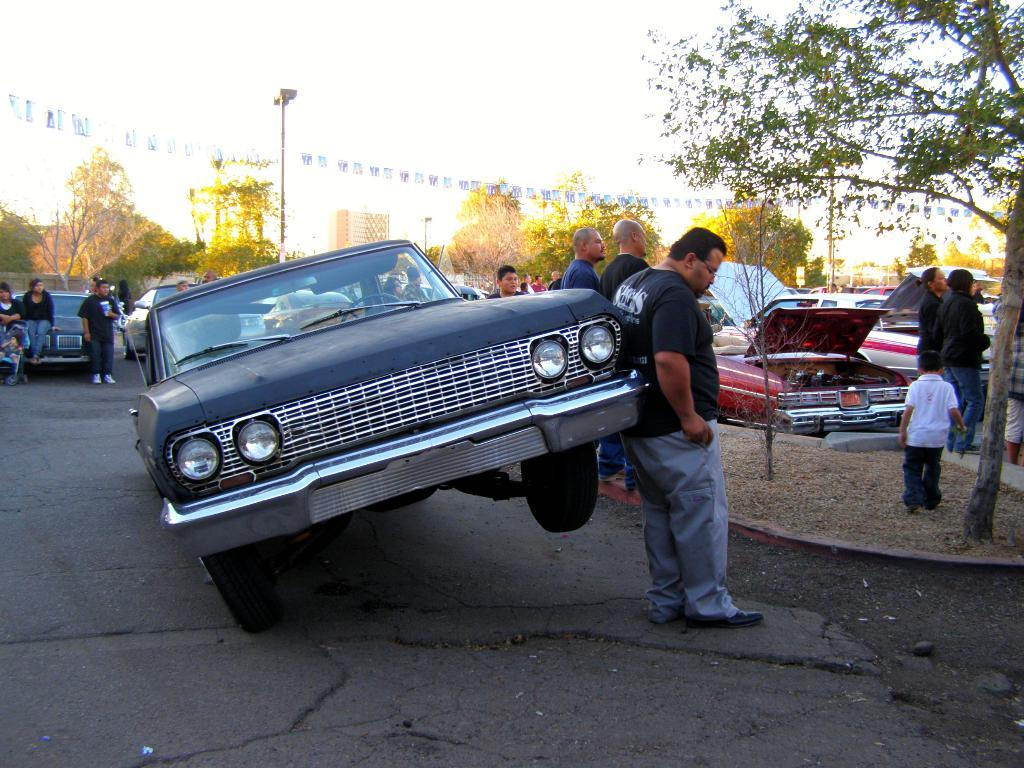What can be seen on the road in the image? There are vehicles and people on the road in the image. What else is visible in the image besides the road? Trees, poles, flags, buildings, and the sky are visible in the image. Can you describe the flags in the image? Yes, there are flags in the image. What is the background of the image? The background of the image includes buildings and the sky. Where is the drawer located in the image? There is no drawer present in the image. What subject is being taught by the people in the image? There is no teaching or subject being taught in the image. 